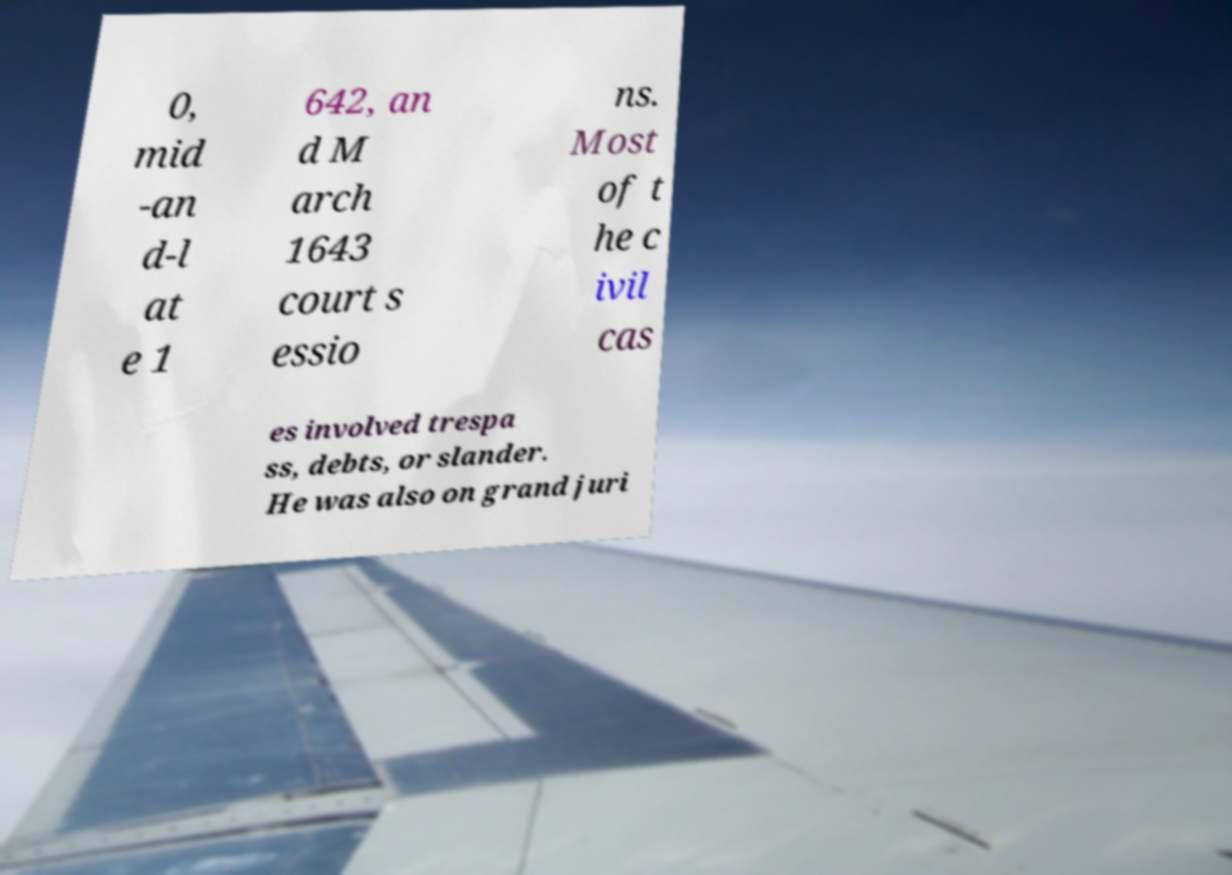What messages or text are displayed in this image? I need them in a readable, typed format. 0, mid -an d-l at e 1 642, an d M arch 1643 court s essio ns. Most of t he c ivil cas es involved trespa ss, debts, or slander. He was also on grand juri 